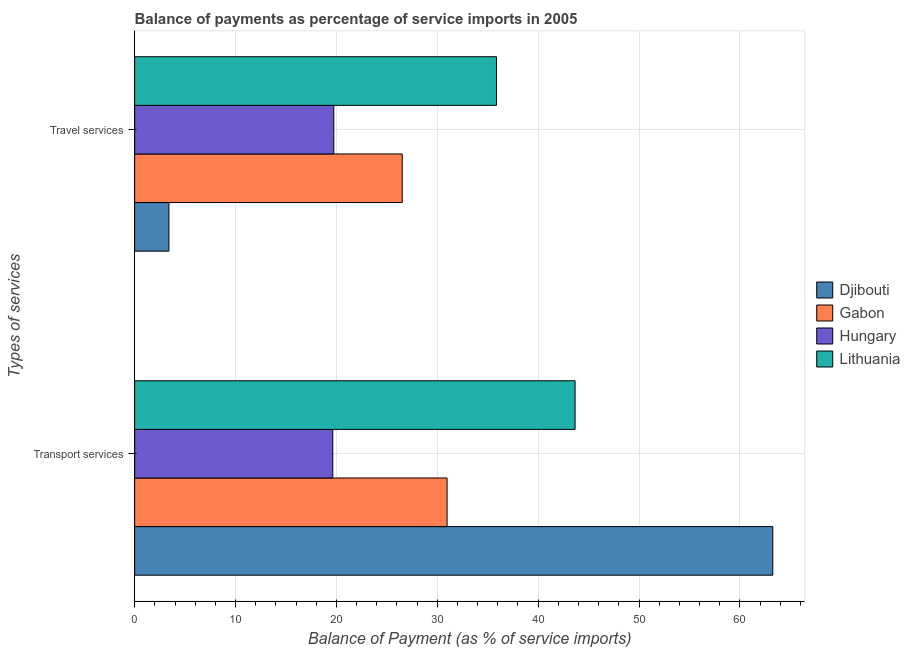How many groups of bars are there?
Your answer should be very brief. 2. Are the number of bars on each tick of the Y-axis equal?
Ensure brevity in your answer.  Yes. What is the label of the 1st group of bars from the top?
Your answer should be compact. Travel services. What is the balance of payments of transport services in Lithuania?
Give a very brief answer. 43.66. Across all countries, what is the maximum balance of payments of transport services?
Your answer should be very brief. 63.26. Across all countries, what is the minimum balance of payments of travel services?
Your answer should be compact. 3.4. In which country was the balance of payments of transport services maximum?
Offer a terse response. Djibouti. In which country was the balance of payments of travel services minimum?
Keep it short and to the point. Djibouti. What is the total balance of payments of transport services in the graph?
Provide a short and direct response. 157.53. What is the difference between the balance of payments of travel services in Lithuania and that in Hungary?
Your answer should be very brief. 16.12. What is the difference between the balance of payments of transport services in Djibouti and the balance of payments of travel services in Lithuania?
Make the answer very short. 27.39. What is the average balance of payments of transport services per country?
Your answer should be very brief. 39.38. What is the difference between the balance of payments of travel services and balance of payments of transport services in Hungary?
Your answer should be compact. 0.1. In how many countries, is the balance of payments of travel services greater than 30 %?
Ensure brevity in your answer.  1. What is the ratio of the balance of payments of transport services in Djibouti to that in Gabon?
Offer a terse response. 2.04. What does the 2nd bar from the top in Transport services represents?
Make the answer very short. Hungary. What does the 1st bar from the bottom in Transport services represents?
Your answer should be compact. Djibouti. How many bars are there?
Offer a very short reply. 8. How many countries are there in the graph?
Your answer should be compact. 4. Does the graph contain any zero values?
Your response must be concise. No. Does the graph contain grids?
Your answer should be very brief. Yes. What is the title of the graph?
Your answer should be compact. Balance of payments as percentage of service imports in 2005. What is the label or title of the X-axis?
Your response must be concise. Balance of Payment (as % of service imports). What is the label or title of the Y-axis?
Give a very brief answer. Types of services. What is the Balance of Payment (as % of service imports) in Djibouti in Transport services?
Ensure brevity in your answer.  63.26. What is the Balance of Payment (as % of service imports) in Gabon in Transport services?
Offer a very short reply. 30.97. What is the Balance of Payment (as % of service imports) of Hungary in Transport services?
Offer a terse response. 19.64. What is the Balance of Payment (as % of service imports) in Lithuania in Transport services?
Offer a very short reply. 43.66. What is the Balance of Payment (as % of service imports) of Djibouti in Travel services?
Your answer should be compact. 3.4. What is the Balance of Payment (as % of service imports) of Gabon in Travel services?
Your response must be concise. 26.52. What is the Balance of Payment (as % of service imports) in Hungary in Travel services?
Ensure brevity in your answer.  19.74. What is the Balance of Payment (as % of service imports) of Lithuania in Travel services?
Make the answer very short. 35.87. Across all Types of services, what is the maximum Balance of Payment (as % of service imports) in Djibouti?
Keep it short and to the point. 63.26. Across all Types of services, what is the maximum Balance of Payment (as % of service imports) in Gabon?
Provide a short and direct response. 30.97. Across all Types of services, what is the maximum Balance of Payment (as % of service imports) of Hungary?
Provide a succinct answer. 19.74. Across all Types of services, what is the maximum Balance of Payment (as % of service imports) of Lithuania?
Keep it short and to the point. 43.66. Across all Types of services, what is the minimum Balance of Payment (as % of service imports) of Djibouti?
Your answer should be compact. 3.4. Across all Types of services, what is the minimum Balance of Payment (as % of service imports) in Gabon?
Keep it short and to the point. 26.52. Across all Types of services, what is the minimum Balance of Payment (as % of service imports) in Hungary?
Offer a very short reply. 19.64. Across all Types of services, what is the minimum Balance of Payment (as % of service imports) in Lithuania?
Offer a very short reply. 35.87. What is the total Balance of Payment (as % of service imports) of Djibouti in the graph?
Your response must be concise. 66.66. What is the total Balance of Payment (as % of service imports) in Gabon in the graph?
Keep it short and to the point. 57.49. What is the total Balance of Payment (as % of service imports) of Hungary in the graph?
Your answer should be very brief. 39.38. What is the total Balance of Payment (as % of service imports) of Lithuania in the graph?
Ensure brevity in your answer.  79.53. What is the difference between the Balance of Payment (as % of service imports) in Djibouti in Transport services and that in Travel services?
Your answer should be compact. 59.86. What is the difference between the Balance of Payment (as % of service imports) in Gabon in Transport services and that in Travel services?
Your answer should be very brief. 4.45. What is the difference between the Balance of Payment (as % of service imports) in Hungary in Transport services and that in Travel services?
Give a very brief answer. -0.1. What is the difference between the Balance of Payment (as % of service imports) in Lithuania in Transport services and that in Travel services?
Your response must be concise. 7.79. What is the difference between the Balance of Payment (as % of service imports) in Djibouti in Transport services and the Balance of Payment (as % of service imports) in Gabon in Travel services?
Provide a short and direct response. 36.74. What is the difference between the Balance of Payment (as % of service imports) of Djibouti in Transport services and the Balance of Payment (as % of service imports) of Hungary in Travel services?
Ensure brevity in your answer.  43.52. What is the difference between the Balance of Payment (as % of service imports) in Djibouti in Transport services and the Balance of Payment (as % of service imports) in Lithuania in Travel services?
Make the answer very short. 27.39. What is the difference between the Balance of Payment (as % of service imports) in Gabon in Transport services and the Balance of Payment (as % of service imports) in Hungary in Travel services?
Give a very brief answer. 11.23. What is the difference between the Balance of Payment (as % of service imports) in Gabon in Transport services and the Balance of Payment (as % of service imports) in Lithuania in Travel services?
Offer a very short reply. -4.9. What is the difference between the Balance of Payment (as % of service imports) of Hungary in Transport services and the Balance of Payment (as % of service imports) of Lithuania in Travel services?
Provide a succinct answer. -16.23. What is the average Balance of Payment (as % of service imports) of Djibouti per Types of services?
Provide a succinct answer. 33.33. What is the average Balance of Payment (as % of service imports) in Gabon per Types of services?
Make the answer very short. 28.75. What is the average Balance of Payment (as % of service imports) of Hungary per Types of services?
Provide a short and direct response. 19.69. What is the average Balance of Payment (as % of service imports) in Lithuania per Types of services?
Provide a succinct answer. 39.76. What is the difference between the Balance of Payment (as % of service imports) in Djibouti and Balance of Payment (as % of service imports) in Gabon in Transport services?
Your response must be concise. 32.29. What is the difference between the Balance of Payment (as % of service imports) in Djibouti and Balance of Payment (as % of service imports) in Hungary in Transport services?
Your answer should be compact. 43.62. What is the difference between the Balance of Payment (as % of service imports) in Djibouti and Balance of Payment (as % of service imports) in Lithuania in Transport services?
Your response must be concise. 19.6. What is the difference between the Balance of Payment (as % of service imports) of Gabon and Balance of Payment (as % of service imports) of Hungary in Transport services?
Your response must be concise. 11.33. What is the difference between the Balance of Payment (as % of service imports) of Gabon and Balance of Payment (as % of service imports) of Lithuania in Transport services?
Offer a terse response. -12.69. What is the difference between the Balance of Payment (as % of service imports) of Hungary and Balance of Payment (as % of service imports) of Lithuania in Transport services?
Keep it short and to the point. -24.02. What is the difference between the Balance of Payment (as % of service imports) in Djibouti and Balance of Payment (as % of service imports) in Gabon in Travel services?
Give a very brief answer. -23.13. What is the difference between the Balance of Payment (as % of service imports) of Djibouti and Balance of Payment (as % of service imports) of Hungary in Travel services?
Make the answer very short. -16.34. What is the difference between the Balance of Payment (as % of service imports) in Djibouti and Balance of Payment (as % of service imports) in Lithuania in Travel services?
Provide a succinct answer. -32.47. What is the difference between the Balance of Payment (as % of service imports) of Gabon and Balance of Payment (as % of service imports) of Hungary in Travel services?
Offer a very short reply. 6.78. What is the difference between the Balance of Payment (as % of service imports) in Gabon and Balance of Payment (as % of service imports) in Lithuania in Travel services?
Ensure brevity in your answer.  -9.34. What is the difference between the Balance of Payment (as % of service imports) in Hungary and Balance of Payment (as % of service imports) in Lithuania in Travel services?
Ensure brevity in your answer.  -16.12. What is the ratio of the Balance of Payment (as % of service imports) of Djibouti in Transport services to that in Travel services?
Offer a terse response. 18.62. What is the ratio of the Balance of Payment (as % of service imports) in Gabon in Transport services to that in Travel services?
Provide a short and direct response. 1.17. What is the ratio of the Balance of Payment (as % of service imports) in Hungary in Transport services to that in Travel services?
Your answer should be very brief. 0.99. What is the ratio of the Balance of Payment (as % of service imports) of Lithuania in Transport services to that in Travel services?
Provide a succinct answer. 1.22. What is the difference between the highest and the second highest Balance of Payment (as % of service imports) of Djibouti?
Make the answer very short. 59.86. What is the difference between the highest and the second highest Balance of Payment (as % of service imports) of Gabon?
Ensure brevity in your answer.  4.45. What is the difference between the highest and the second highest Balance of Payment (as % of service imports) of Hungary?
Your response must be concise. 0.1. What is the difference between the highest and the second highest Balance of Payment (as % of service imports) of Lithuania?
Ensure brevity in your answer.  7.79. What is the difference between the highest and the lowest Balance of Payment (as % of service imports) of Djibouti?
Keep it short and to the point. 59.86. What is the difference between the highest and the lowest Balance of Payment (as % of service imports) of Gabon?
Make the answer very short. 4.45. What is the difference between the highest and the lowest Balance of Payment (as % of service imports) of Hungary?
Your answer should be very brief. 0.1. What is the difference between the highest and the lowest Balance of Payment (as % of service imports) in Lithuania?
Provide a short and direct response. 7.79. 